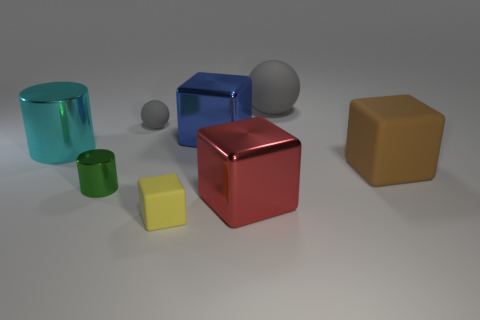Subtract all small blocks. How many blocks are left? 3 Subtract all yellow cubes. How many cubes are left? 3 Add 1 tiny gray things. How many objects exist? 9 Subtract all cylinders. How many objects are left? 6 Subtract all purple blocks. Subtract all gray cylinders. How many blocks are left? 4 Add 3 tiny gray matte spheres. How many tiny gray matte spheres exist? 4 Subtract 0 red cylinders. How many objects are left? 8 Subtract all big blue blocks. Subtract all big shiny things. How many objects are left? 4 Add 1 small matte spheres. How many small matte spheres are left? 2 